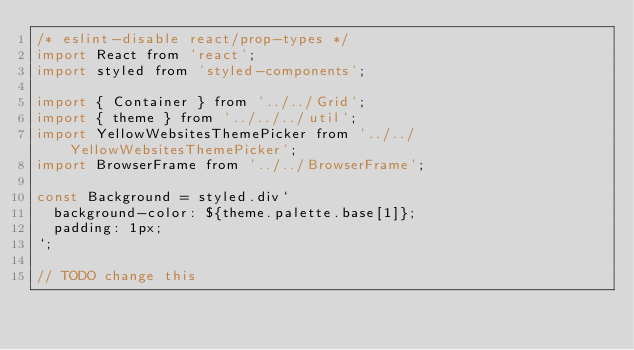Convert code to text. <code><loc_0><loc_0><loc_500><loc_500><_JavaScript_>/* eslint-disable react/prop-types */
import React from 'react';
import styled from 'styled-components';

import { Container } from '../../Grid';
import { theme } from '../../../util';
import YellowWebsitesThemePicker from '../../YellowWebsitesThemePicker';
import BrowserFrame from '../../BrowserFrame';

const Background = styled.div`
  background-color: ${theme.palette.base[1]};
  padding: 1px;
`;

// TODO change this</code> 